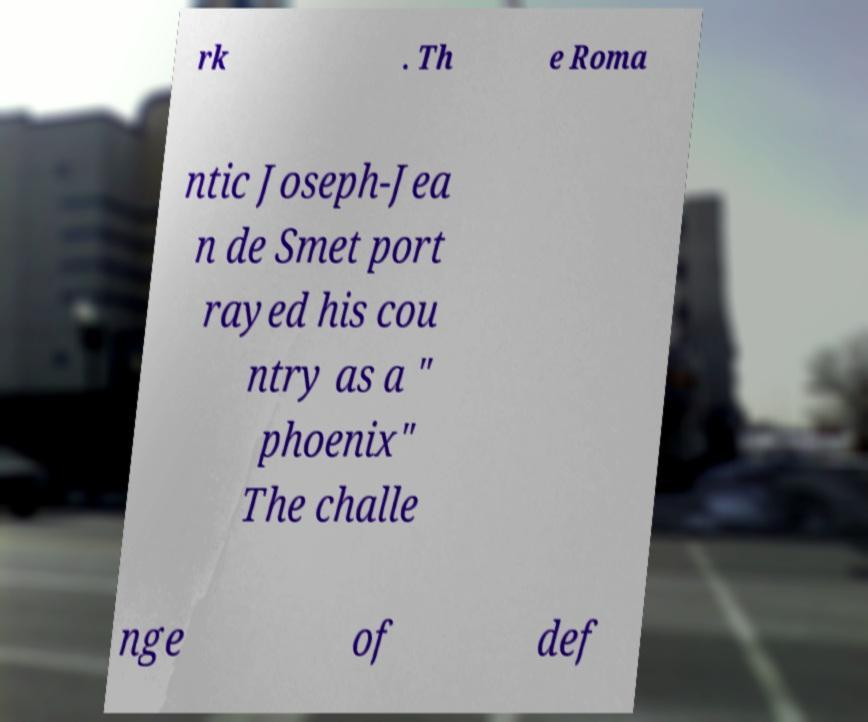Please read and relay the text visible in this image. What does it say? rk . Th e Roma ntic Joseph-Jea n de Smet port rayed his cou ntry as a " phoenix" The challe nge of def 